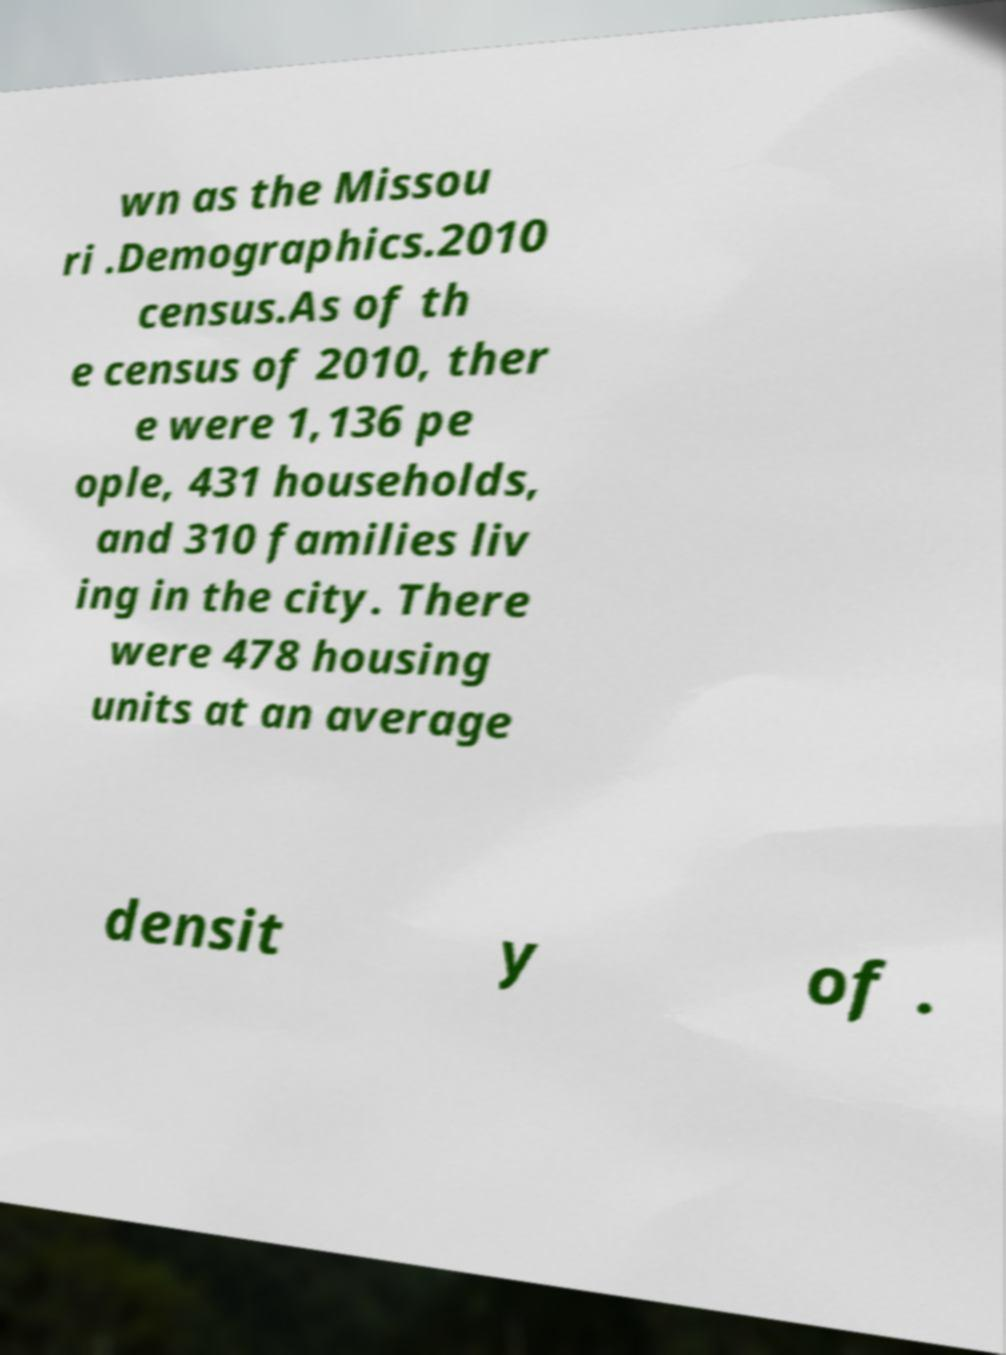Could you assist in decoding the text presented in this image and type it out clearly? wn as the Missou ri .Demographics.2010 census.As of th e census of 2010, ther e were 1,136 pe ople, 431 households, and 310 families liv ing in the city. There were 478 housing units at an average densit y of . 